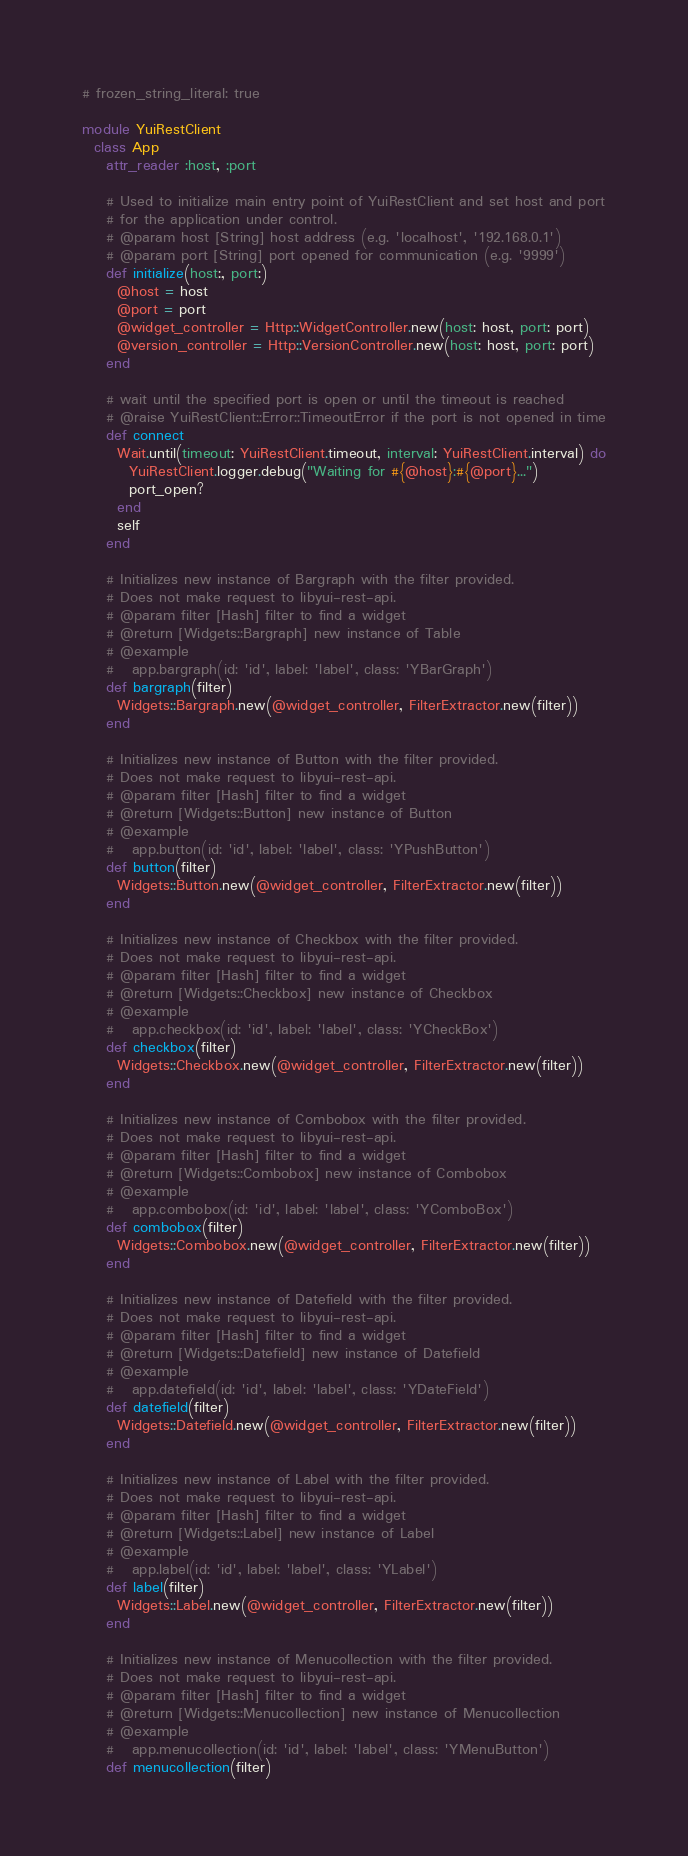<code> <loc_0><loc_0><loc_500><loc_500><_Ruby_># frozen_string_literal: true

module YuiRestClient
  class App
    attr_reader :host, :port

    # Used to initialize main entry point of YuiRestClient and set host and port
    # for the application under control.
    # @param host [String] host address (e.g. 'localhost', '192.168.0.1')
    # @param port [String] port opened for communication (e.g. '9999')
    def initialize(host:, port:)
      @host = host
      @port = port
      @widget_controller = Http::WidgetController.new(host: host, port: port)
      @version_controller = Http::VersionController.new(host: host, port: port)
    end

    # wait until the specified port is open or until the timeout is reached
    # @raise YuiRestClient::Error::TimeoutError if the port is not opened in time
    def connect
      Wait.until(timeout: YuiRestClient.timeout, interval: YuiRestClient.interval) do
        YuiRestClient.logger.debug("Waiting for #{@host}:#{@port}...")
        port_open?
      end
      self
    end

    # Initializes new instance of Bargraph with the filter provided.
    # Does not make request to libyui-rest-api.
    # @param filter [Hash] filter to find a widget
    # @return [Widgets::Bargraph] new instance of Table
    # @example
    #   app.bargraph(id: 'id', label: 'label', class: 'YBarGraph')
    def bargraph(filter)
      Widgets::Bargraph.new(@widget_controller, FilterExtractor.new(filter))
    end

    # Initializes new instance of Button with the filter provided.
    # Does not make request to libyui-rest-api.
    # @param filter [Hash] filter to find a widget
    # @return [Widgets::Button] new instance of Button
    # @example
    #   app.button(id: 'id', label: 'label', class: 'YPushButton')
    def button(filter)
      Widgets::Button.new(@widget_controller, FilterExtractor.new(filter))
    end

    # Initializes new instance of Checkbox with the filter provided.
    # Does not make request to libyui-rest-api.
    # @param filter [Hash] filter to find a widget
    # @return [Widgets::Checkbox] new instance of Checkbox
    # @example
    #   app.checkbox(id: 'id', label: 'label', class: 'YCheckBox')
    def checkbox(filter)
      Widgets::Checkbox.new(@widget_controller, FilterExtractor.new(filter))
    end

    # Initializes new instance of Combobox with the filter provided.
    # Does not make request to libyui-rest-api.
    # @param filter [Hash] filter to find a widget
    # @return [Widgets::Combobox] new instance of Combobox
    # @example
    #   app.combobox(id: 'id', label: 'label', class: 'YComboBox')
    def combobox(filter)
      Widgets::Combobox.new(@widget_controller, FilterExtractor.new(filter))
    end

    # Initializes new instance of Datefield with the filter provided.
    # Does not make request to libyui-rest-api.
    # @param filter [Hash] filter to find a widget
    # @return [Widgets::Datefield] new instance of Datefield
    # @example
    #   app.datefield(id: 'id', label: 'label', class: 'YDateField')
    def datefield(filter)
      Widgets::Datefield.new(@widget_controller, FilterExtractor.new(filter))
    end

    # Initializes new instance of Label with the filter provided.
    # Does not make request to libyui-rest-api.
    # @param filter [Hash] filter to find a widget
    # @return [Widgets::Label] new instance of Label
    # @example
    #   app.label(id: 'id', label: 'label', class: 'YLabel')
    def label(filter)
      Widgets::Label.new(@widget_controller, FilterExtractor.new(filter))
    end

    # Initializes new instance of Menucollection with the filter provided.
    # Does not make request to libyui-rest-api.
    # @param filter [Hash] filter to find a widget
    # @return [Widgets::Menucollection] new instance of Menucollection
    # @example
    #   app.menucollection(id: 'id', label: 'label', class: 'YMenuButton')
    def menucollection(filter)</code> 